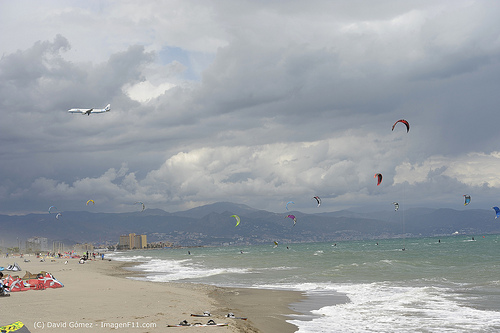Please provide a short description for this region: [0.13, 0.36, 0.22, 0.4]. The region with the bounding box coordinates [0.13, 0.36, 0.22, 0.4] contains a white airplane. 